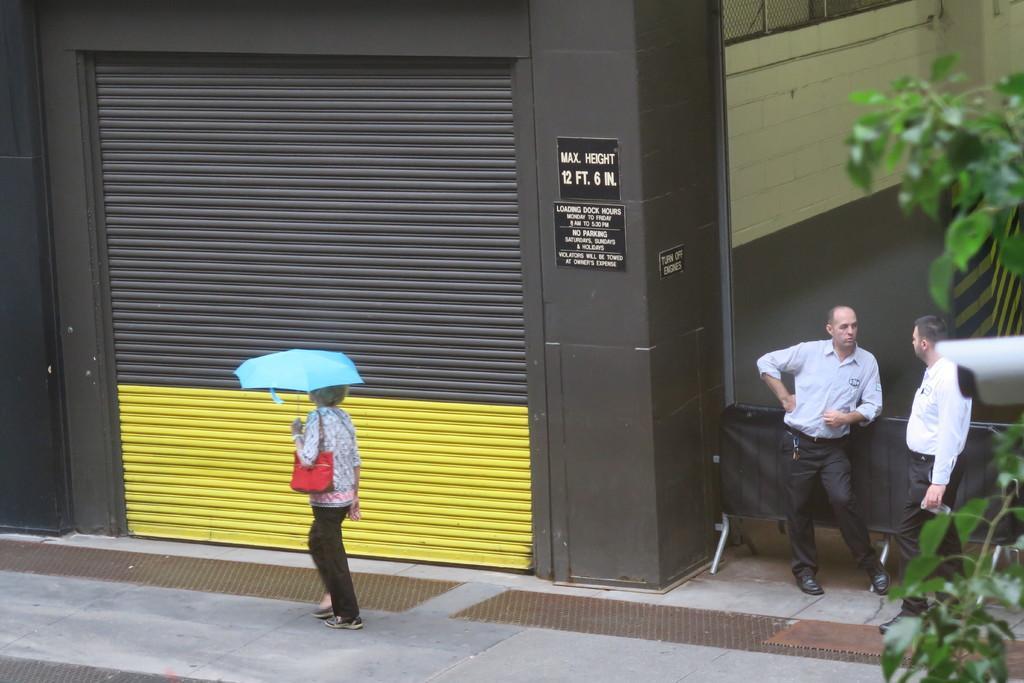Could you give a brief overview of what you see in this image? In this picture there is a woman walking and holding the umbrella. On the right side of the image there are two people standing. At the back there is a building and there are boards on the wall and there is text on the boards and there is a shutter. On the right side of the image there is a tree and it looks like a cc camera. At the bottom there is a footpath. 